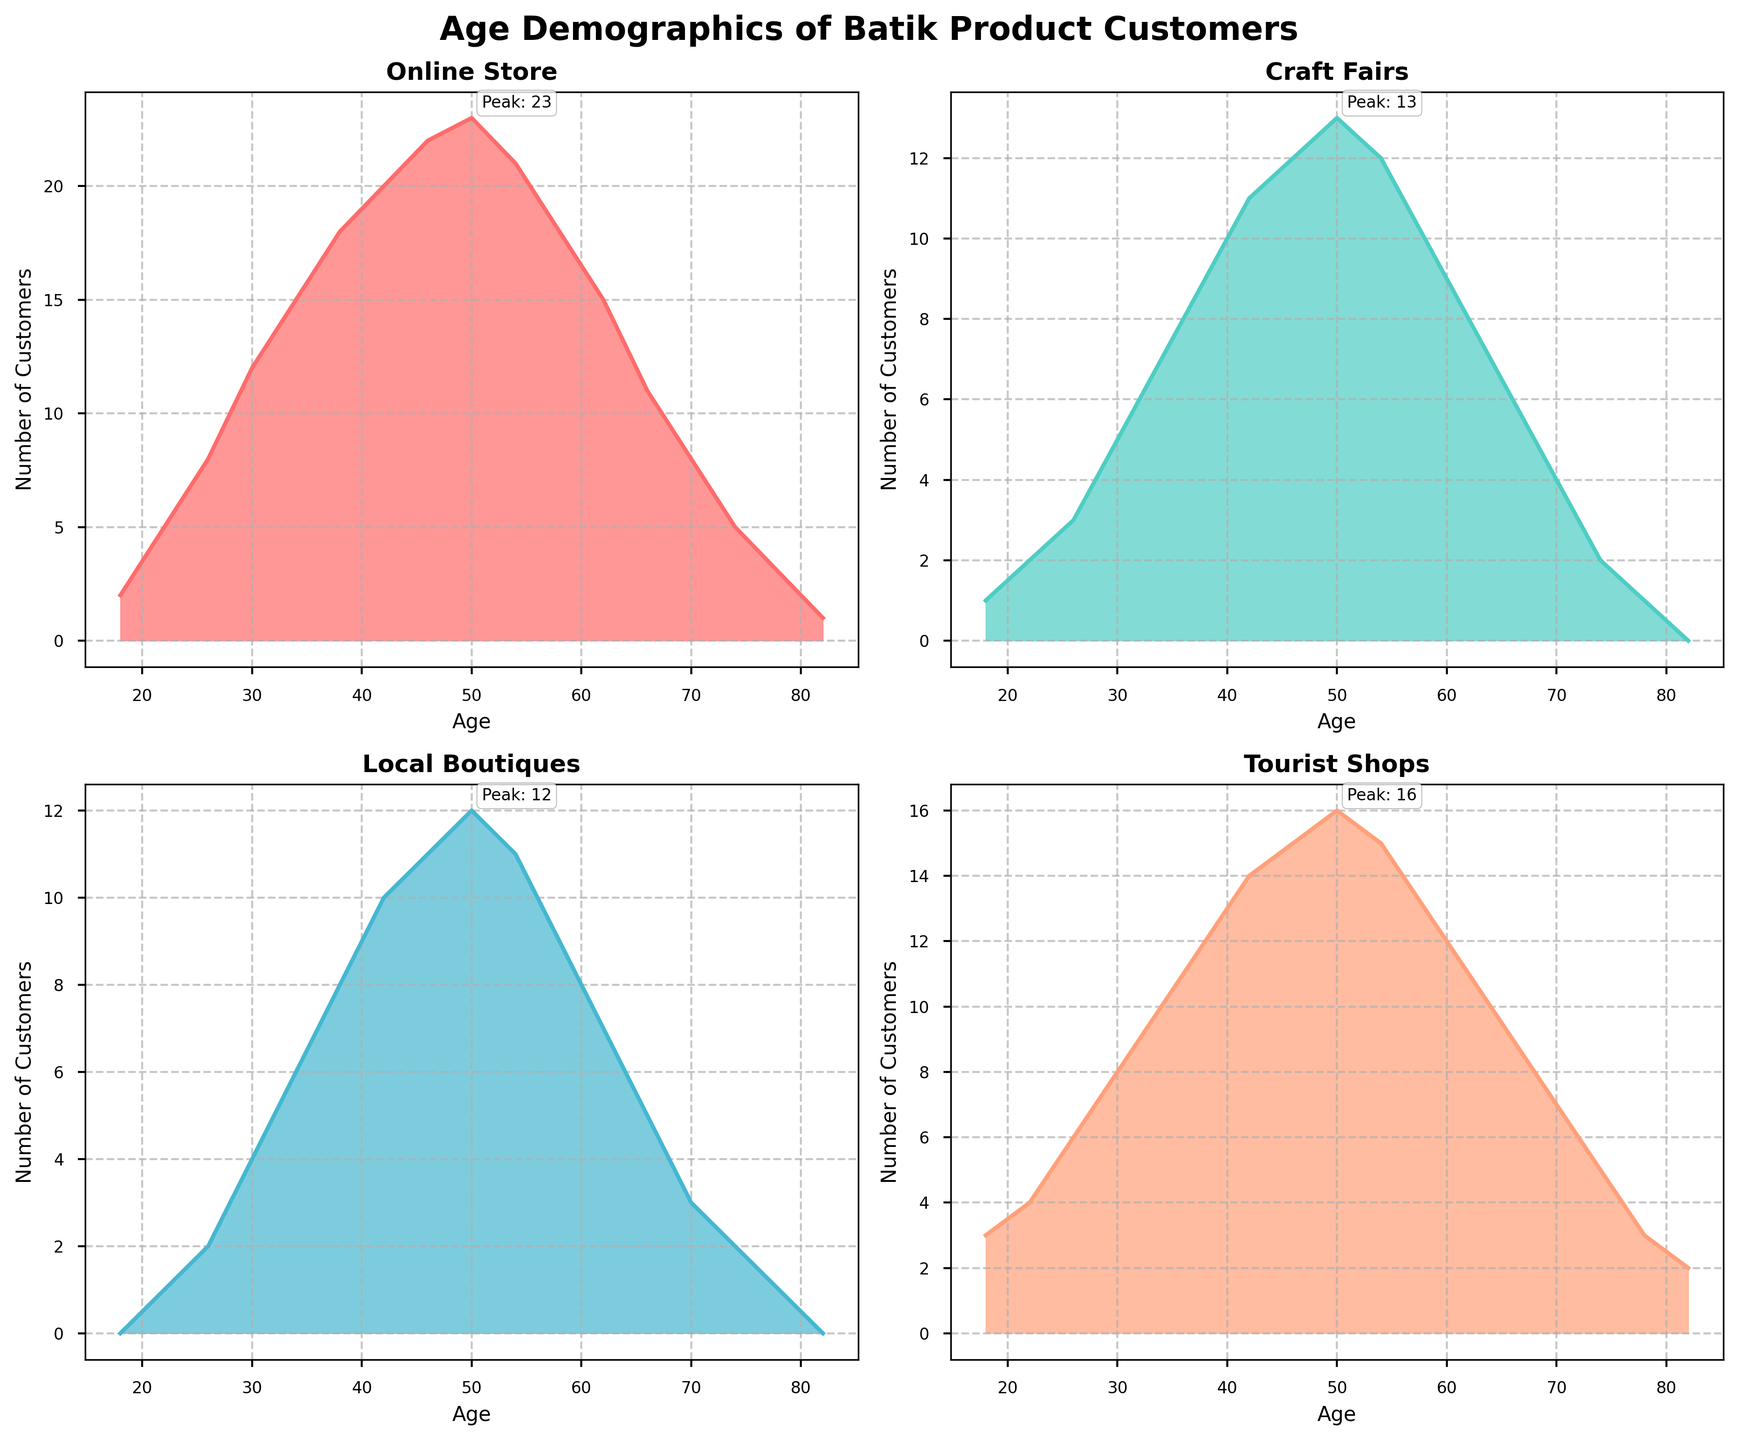Which sales channel has the title 'Online Store'? Look at the subplot titles to locate 'Online Store'. The subplot titled 'Online Store' corresponds to that channel.
Answer: Online Store What color represents 'Craft Fairs' sales channel? Identify the color used in the 'Craft Fairs' subplot by looking at the filled area and the line.
Answer: Turquoise (light greenish-blue) Which age group peaks at 23 customers in 'Online Store'? Look at the 'Online Store' subplot and find the point where the number of customers is 23. The age corresponding to this value is when it peaks.
Answer: 50 What is the lowest value of customers in 'Tourist Shops'? Find the minimum point in the 'Tourist Shops' subplot by looking at the density plot's lowest point.
Answer: 2 How many age groups have a peak number of 13 customers in 'Local Boutiques'? Locate the peaks on 'Local Boutiques' subplot and count how many age groups have the peak value of 13 customers.
Answer: 1 What is the difference in the number of customers at age 42 between 'Online Store' and 'Tourist Shops'? Look at both 'Online Store' and 'Tourist Shops' subplots, find the number of customers at age 42, then subtract the value of ‘Tourist Shops’ from 'Online Store'. 20 - 14 = 6
Answer: 6 At which age does 'Craft Fairs' reach the second highest number of customers? Identify the highest and second highest peaks in the 'Craft Fairs' subplot, then look at the age corresponding to the second highest peak.
Answer: 50 Which sales channel has the highest number of customers at age 34? Compare the number of customers at age 34 across all four subplots. The one with the highest value has the most customers.
Answer: Tourist Shops Does 'Local Boutiques' have more customers at age 26 or age 70? Compare the number of customers in 'Local Boutiques' at ages 26 and 70. Look at the respective points in the subplot.
Answer: Age 26 How do the customer numbers for age 54 compare between 'Craft Fairs' and 'Local Boutiques'? Look at age 54 in both 'Craft Fairs' and 'Local Boutiques' subplots and compare their customer numbers.
Answer: Same (12) 